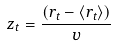Convert formula to latex. <formula><loc_0><loc_0><loc_500><loc_500>z _ { t } = \frac { ( r _ { t } - \langle r _ { t } \rangle ) } { \upsilon }</formula> 